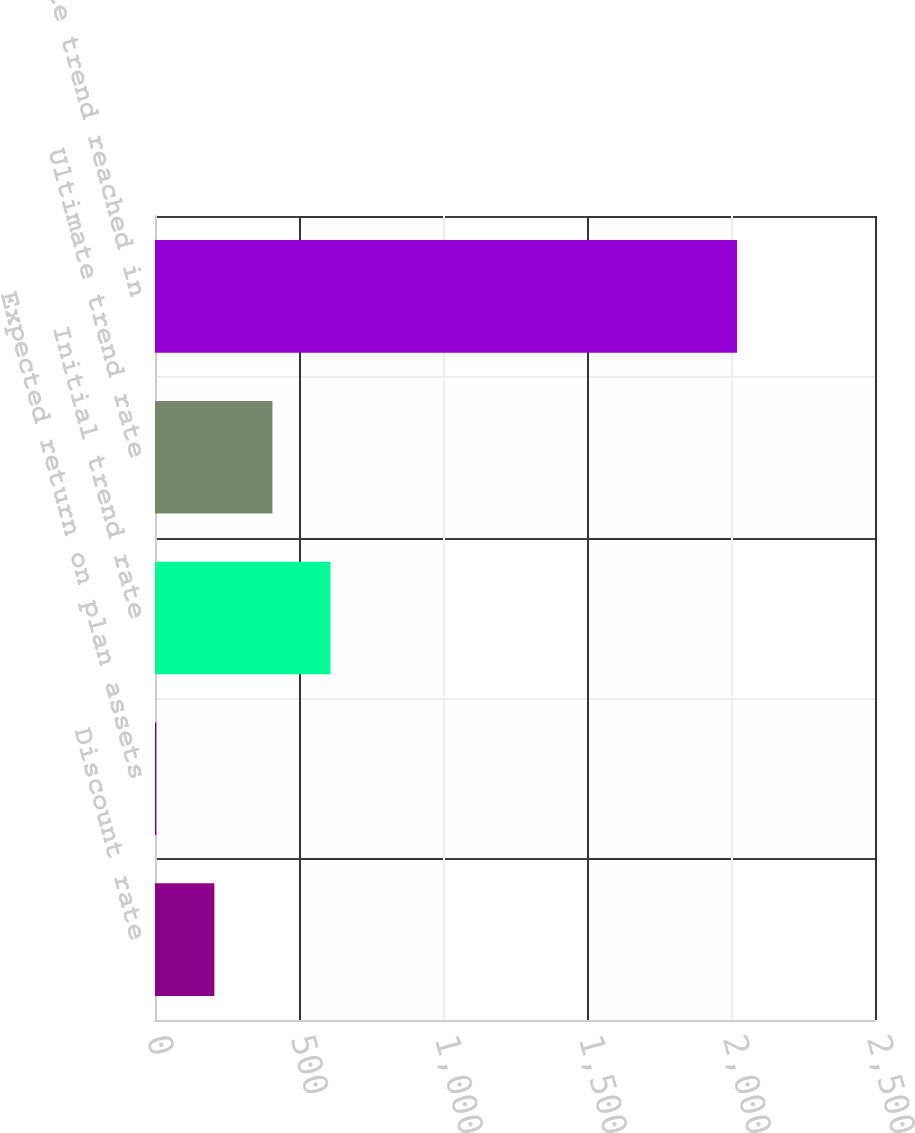Convert chart to OTSL. <chart><loc_0><loc_0><loc_500><loc_500><bar_chart><fcel>Discount rate<fcel>Expected return on plan assets<fcel>Initial trend rate<fcel>Ultimate trend rate<fcel>Ultimate trend reached in<nl><fcel>206.1<fcel>4.45<fcel>609.4<fcel>407.75<fcel>2021<nl></chart> 